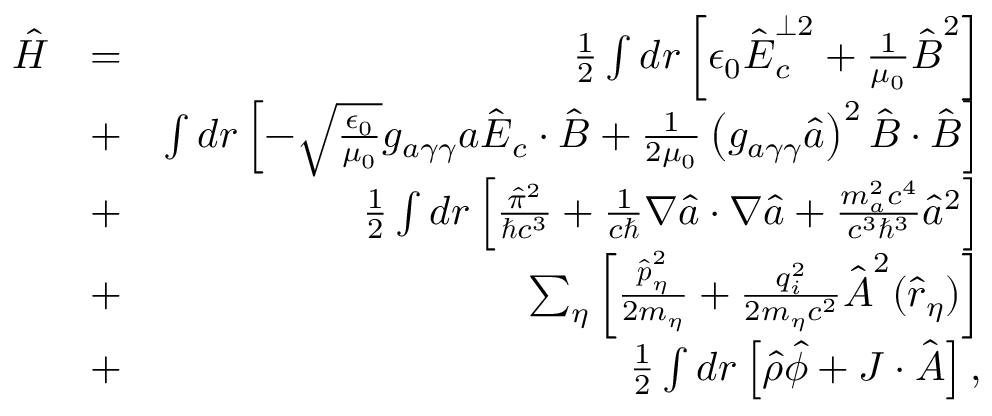<formula> <loc_0><loc_0><loc_500><loc_500>\begin{array} { r l r } { \hat { H } } & { = } & { \frac { 1 } { 2 } \int d \boldsymbol r \left [ \epsilon _ { 0 } \hat { \boldsymbol E } _ { c } ^ { \perp 2 } + \frac { 1 } { \mu _ { 0 } } \hat { \boldsymbol B } ^ { 2 } \right ] } \\ & { + } & { \int d \boldsymbol r \left [ - \sqrt { \frac { \epsilon _ { 0 } } { \mu _ { 0 } } } g _ { a \gamma \gamma } a \hat { \boldsymbol E } _ { c } \cdot \hat { \boldsymbol B } + \frac { 1 } { 2 \mu _ { 0 } } \left ( g _ { a \gamma \gamma } \hat { a } \right ) ^ { 2 } \hat { \boldsymbol B } \cdot \hat { \boldsymbol B } \right ] } \\ & { + } & { \frac { 1 } { 2 } \int d \boldsymbol r \left [ \frac { \hat { \pi } ^ { 2 } } { \hbar { c } ^ { 3 } } + \frac { 1 } { c } \boldsymbol \nabla \hat { a } \cdot \boldsymbol \nabla \hat { a } + \frac { m _ { a } ^ { 2 } c ^ { 4 } } { c ^ { 3 } \hbar { ^ } { 3 } } \hat { a } ^ { 2 } \right ] } \\ & { + } & { \sum _ { \eta } \left [ \frac { \hat { \boldsymbol p } _ { \eta } ^ { 2 } } { 2 m _ { \eta } } + \frac { q _ { i } ^ { 2 } } { 2 m _ { \eta } c ^ { 2 } } \hat { \boldsymbol A } ^ { 2 } ( \hat { \boldsymbol r } _ { \eta } ) \right ] } \\ & { + } & { \frac { 1 } { 2 } \int d \boldsymbol r \left [ \hat { \rho } \hat { \phi } + \boldsymbol J \cdot \hat { \boldsymbol A } \right ] , } \end{array}</formula> 